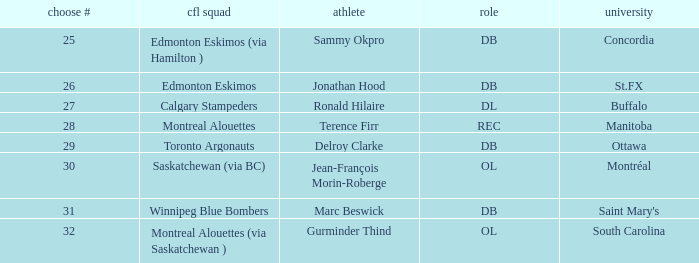Which CFL Team has a Pick # larger than 31? Montreal Alouettes (via Saskatchewan ). 